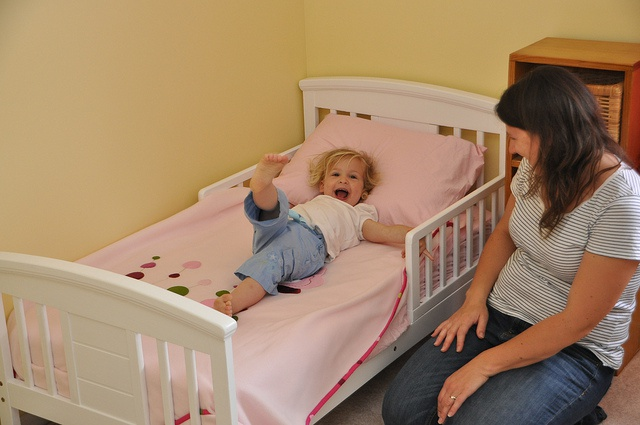Describe the objects in this image and their specific colors. I can see bed in tan and gray tones, people in tan, black, brown, gray, and darkgray tones, and people in tan, salmon, and gray tones in this image. 